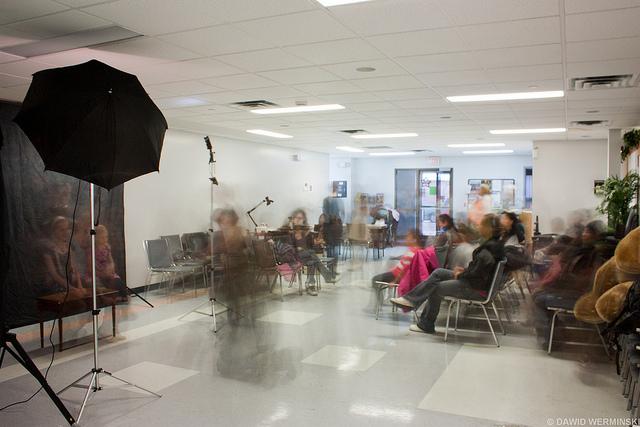What is this picture of?
Quick response, please. Waiting room to get id photo taken. What color is the photo?
Short answer required. White. Is the picture from modern times?
Give a very brief answer. Yes. Was this a long exposure?
Answer briefly. Yes. What device was the ceiling fixture made from?
Be succinct. Tile. Is this a concert?
Be succinct. No. Are people seated?
Write a very short answer. Yes. What is the umbrella used for?
Keep it brief. Photography. What kind of place is this?
Concise answer only. Studio. Is the photo  colorful?
Write a very short answer. Yes. 